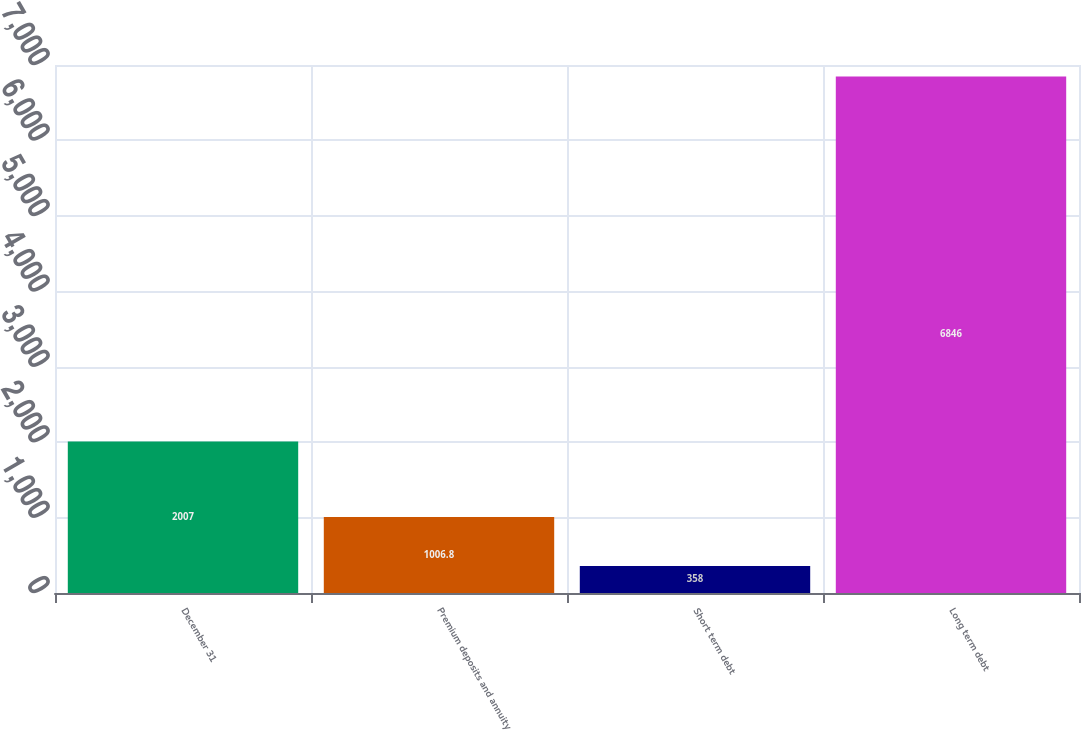Convert chart to OTSL. <chart><loc_0><loc_0><loc_500><loc_500><bar_chart><fcel>December 31<fcel>Premium deposits and annuity<fcel>Short term debt<fcel>Long term debt<nl><fcel>2007<fcel>1006.8<fcel>358<fcel>6846<nl></chart> 